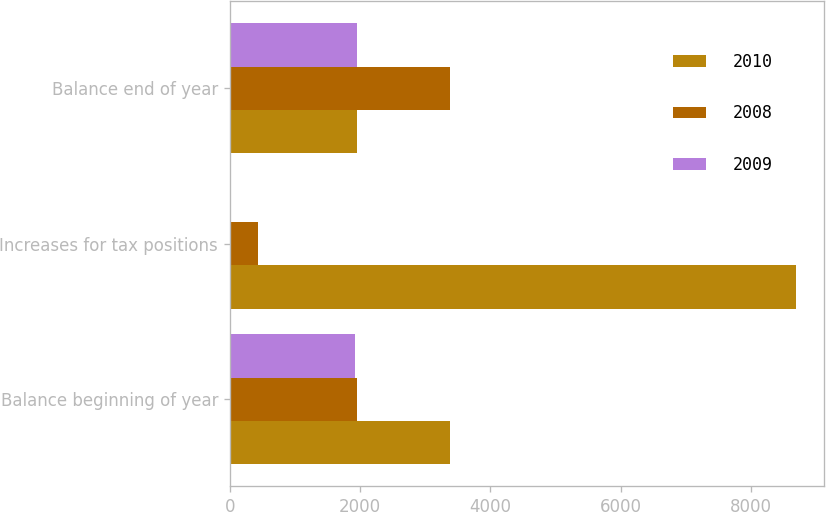Convert chart. <chart><loc_0><loc_0><loc_500><loc_500><stacked_bar_chart><ecel><fcel>Balance beginning of year<fcel>Increases for tax positions<fcel>Balance end of year<nl><fcel>2010<fcel>3387<fcel>8696<fcel>1952<nl><fcel>2008<fcel>1952<fcel>440<fcel>3387<nl><fcel>2009<fcel>1928<fcel>24<fcel>1952<nl></chart> 